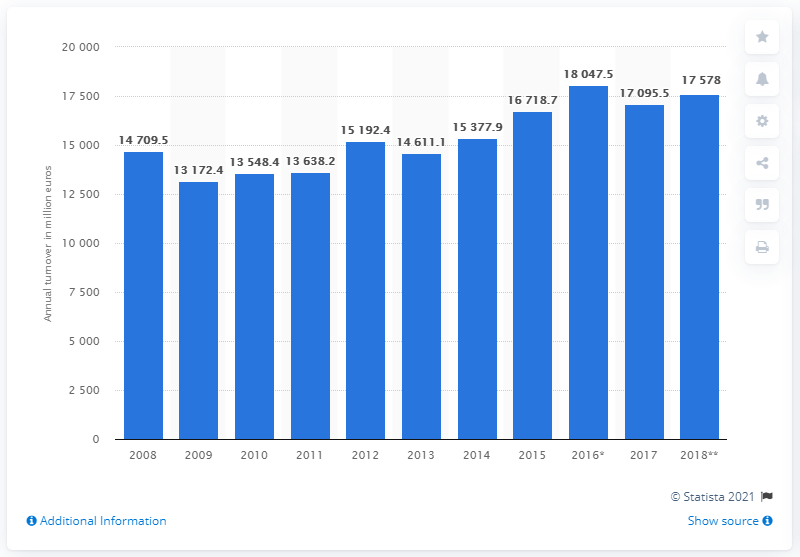Point out several critical features in this image. The total turnover of food, beverage, and tobacco stores in 2018 was 17,578. 